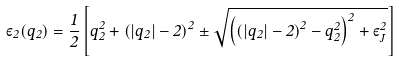Convert formula to latex. <formula><loc_0><loc_0><loc_500><loc_500>\varepsilon _ { 2 } ( q _ { 2 } ) = \frac { 1 } { 2 } \left [ q _ { 2 } ^ { 2 } + \left ( \left | q _ { 2 } \right | - 2 \right ) ^ { 2 } \pm \sqrt { \left ( \left ( \left | q _ { 2 } \right | - 2 \right ) ^ { 2 } - q _ { 2 } ^ { 2 } \right ) ^ { 2 } + \varepsilon _ { J } ^ { 2 } } \right ]</formula> 